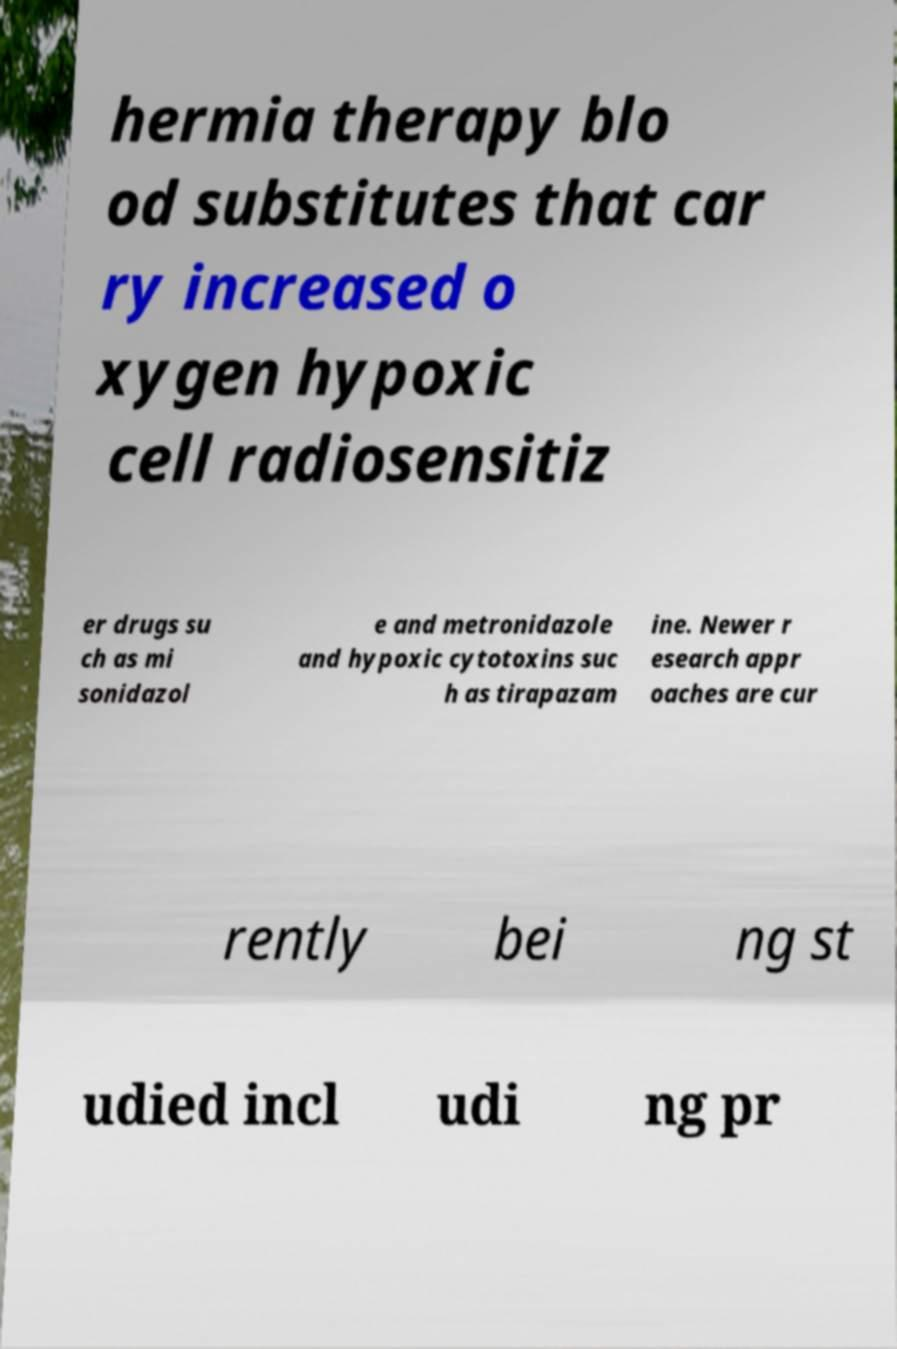For documentation purposes, I need the text within this image transcribed. Could you provide that? hermia therapy blo od substitutes that car ry increased o xygen hypoxic cell radiosensitiz er drugs su ch as mi sonidazol e and metronidazole and hypoxic cytotoxins suc h as tirapazam ine. Newer r esearch appr oaches are cur rently bei ng st udied incl udi ng pr 